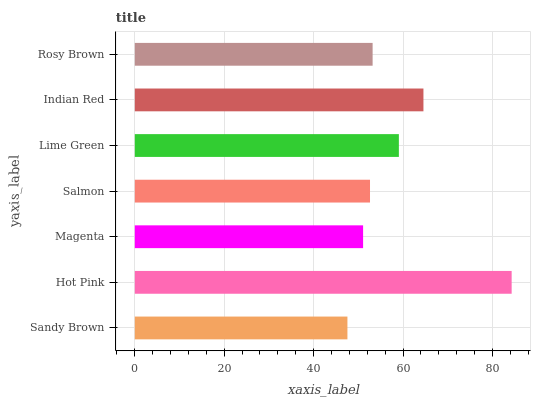Is Sandy Brown the minimum?
Answer yes or no. Yes. Is Hot Pink the maximum?
Answer yes or no. Yes. Is Magenta the minimum?
Answer yes or no. No. Is Magenta the maximum?
Answer yes or no. No. Is Hot Pink greater than Magenta?
Answer yes or no. Yes. Is Magenta less than Hot Pink?
Answer yes or no. Yes. Is Magenta greater than Hot Pink?
Answer yes or no. No. Is Hot Pink less than Magenta?
Answer yes or no. No. Is Rosy Brown the high median?
Answer yes or no. Yes. Is Rosy Brown the low median?
Answer yes or no. Yes. Is Magenta the high median?
Answer yes or no. No. Is Magenta the low median?
Answer yes or no. No. 